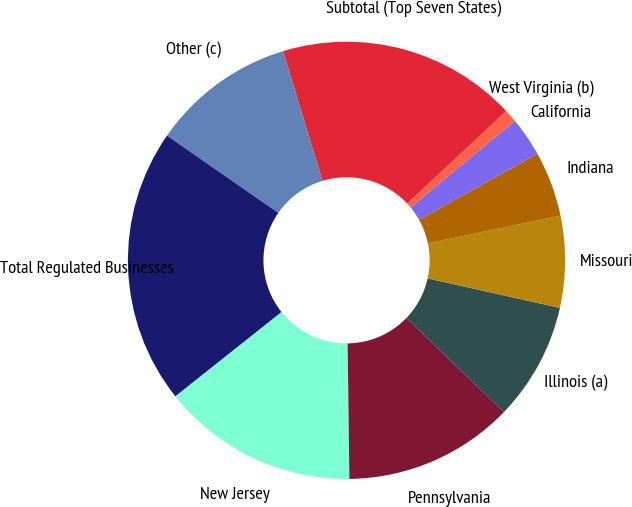<chart> <loc_0><loc_0><loc_500><loc_500><pie_chart><fcel>New Jersey<fcel>Pennsylvania<fcel>Illinois (a)<fcel>Missouri<fcel>Indiana<fcel>California<fcel>West Virginia (b)<fcel>Subtotal (Top Seven States)<fcel>Other (c)<fcel>Total Regulated Businesses<nl><fcel>14.53%<fcel>12.59%<fcel>8.71%<fcel>6.77%<fcel>4.83%<fcel>2.9%<fcel>0.96%<fcel>17.72%<fcel>10.65%<fcel>20.34%<nl></chart> 